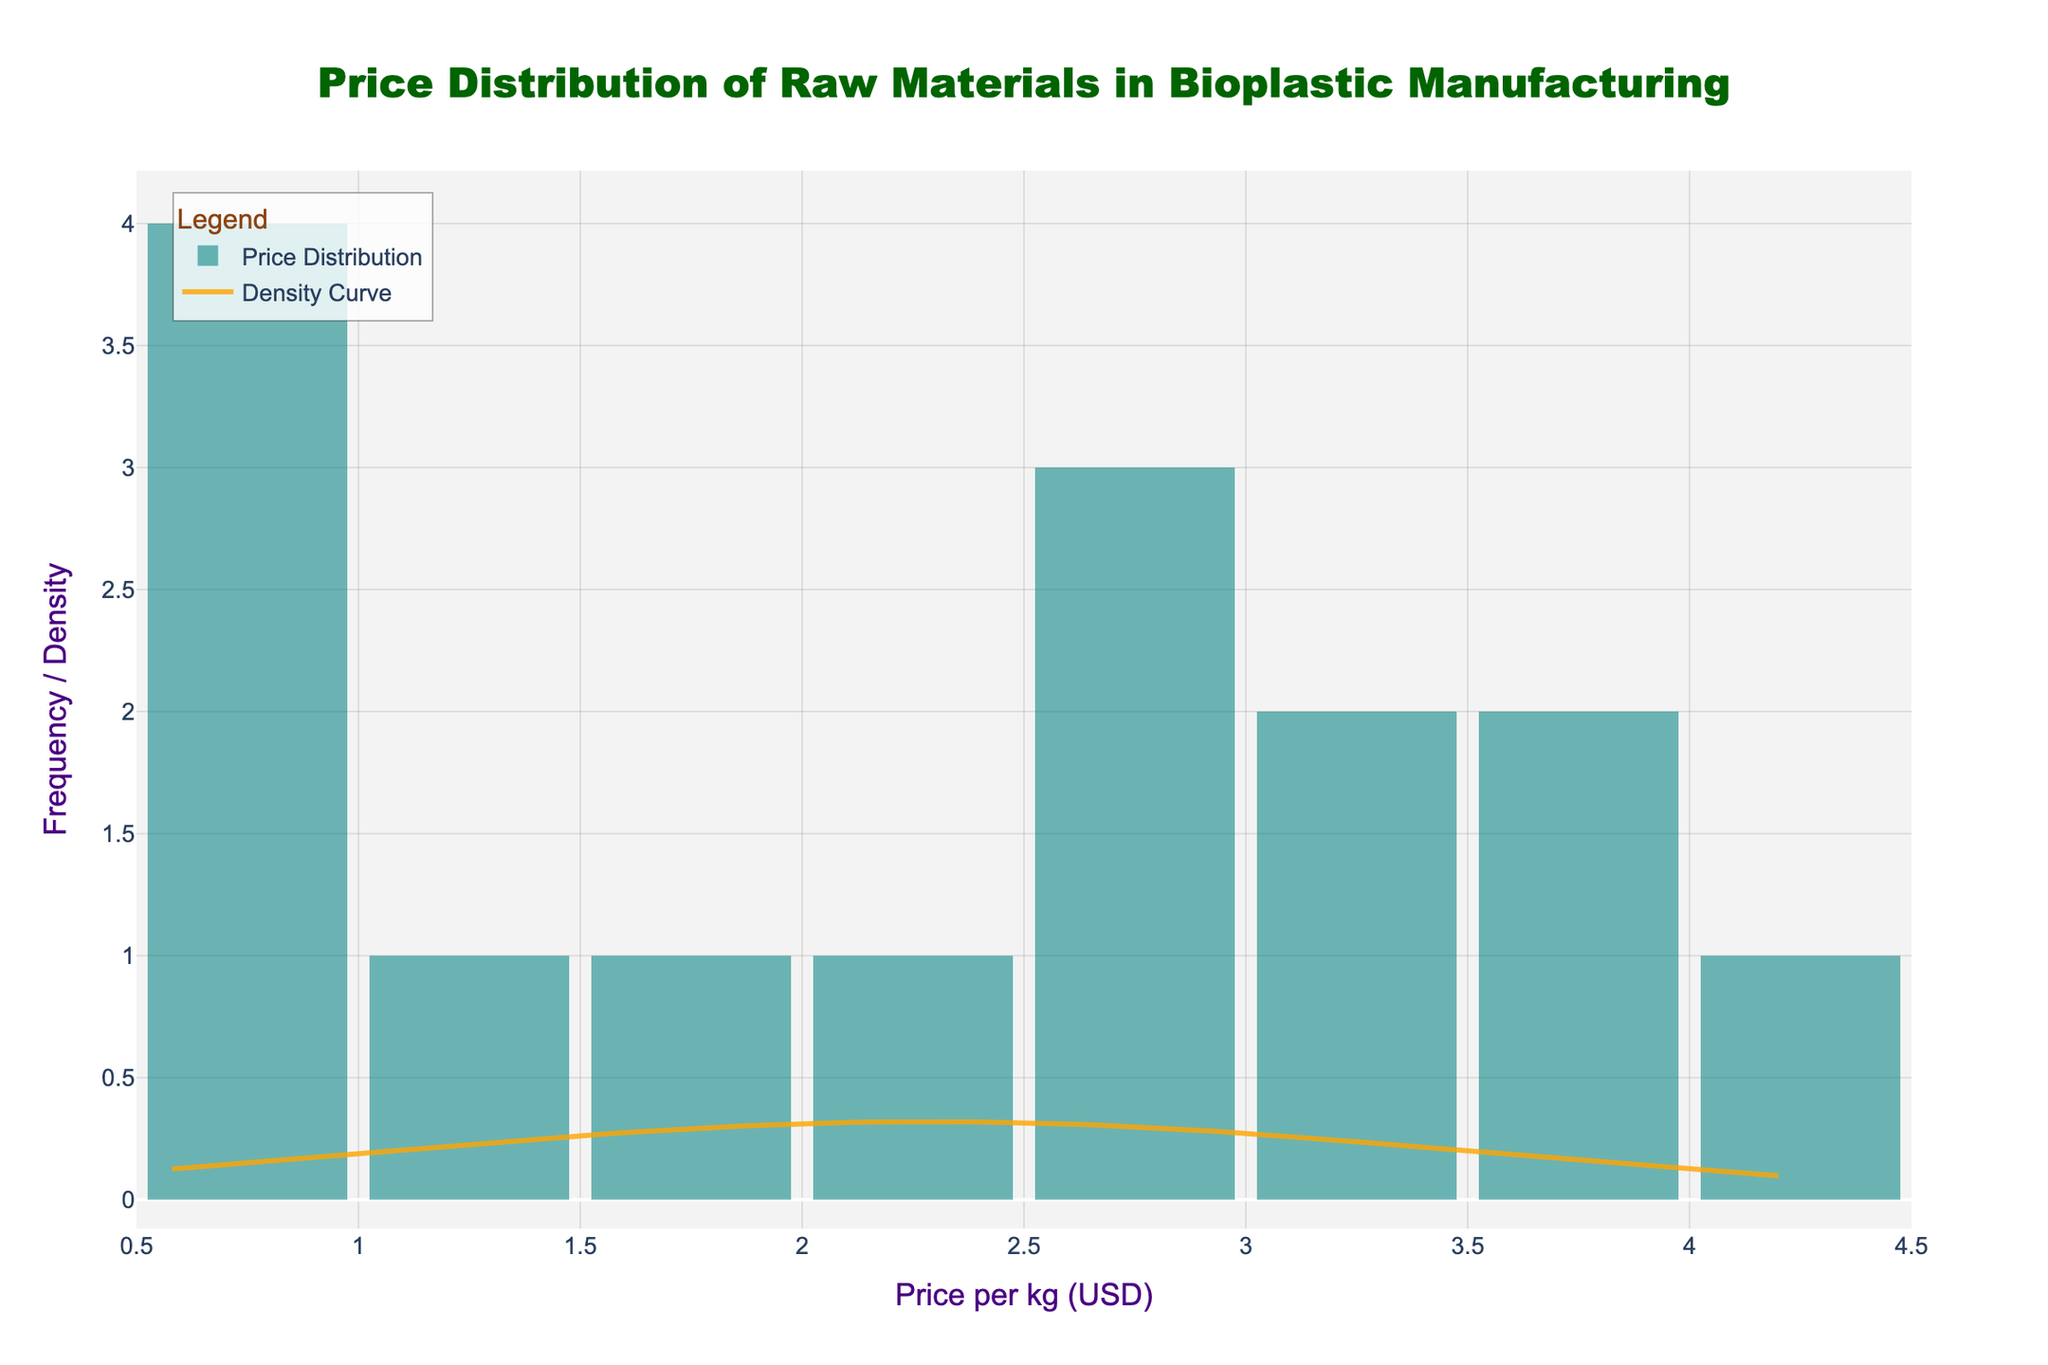What is the title of the figure? The title is clearly displayed at the top of the figure.
Answer: Price Distribution of Raw Materials in Bioplastic Manufacturing What is the color of the histogram bars? The bars are shown in a distinct color in the figure.
Answer: Teal What is the x-axis labeled as? The label for the x-axis is located below the horizontal axis.
Answer: Price per kg (USD) What is the shape of the density curve? The density curve is drawn over the histogram and can be visually inspected.
Answer: Bell-shaped How does the height of the histogram bars vary across different price ranges? Observing the unequal heights of the bars will show how they vary across different price ranges.
Answer: Varies, with a peak followed by a tapering pattern Where is the peak of the density curve located along the x-axis? By examining where the highest point of the curve is located.
Answer: Around $2.00 - $2.50 per kg Which price range has the highest frequency based on the histogram? The tallest histogram bar indicates the price range with the highest frequency.
Answer: $2.00 - $2.50 per kg What is the approximate standard deviation of the prices given the density curve shape? The width of the bell shape gives a visual estimate of standard deviation around the mean.
Answer: Approximately $1.0 What can be inferred about the distribution symmetry from the histogram and density curve? Comparing the shape and spread of both the histogram and the density curve.
Answer: Roughly symmetric Are there any outliers in the price distribution? Observing for any bars that are distinctively apart from the main grouping in the histogram.
Answer: No significant outliers 